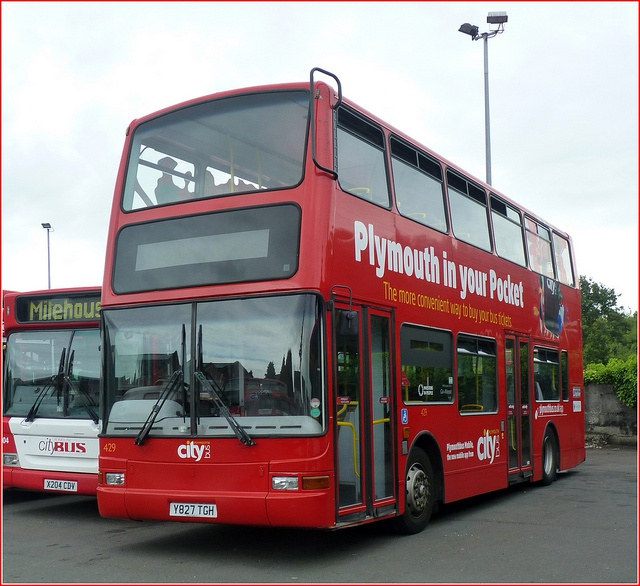Describe the objects in this image and their specific colors. I can see bus in red, black, brown, gray, and darkgray tones and bus in red, black, lightgray, gray, and darkgray tones in this image. 